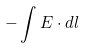<formula> <loc_0><loc_0><loc_500><loc_500>- \int E \cdot d l</formula> 